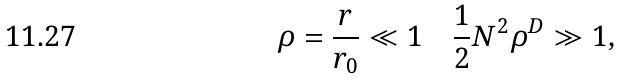Convert formula to latex. <formula><loc_0><loc_0><loc_500><loc_500>\rho = \frac { r } { r _ { 0 } } \ll 1 \quad \frac { 1 } { 2 } N ^ { 2 } \rho ^ { D } \gg 1 ,</formula> 